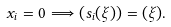<formula> <loc_0><loc_0><loc_500><loc_500>x _ { i } = 0 \Longrightarrow ( s _ { i } ( \xi ) ) = ( \xi ) .</formula> 